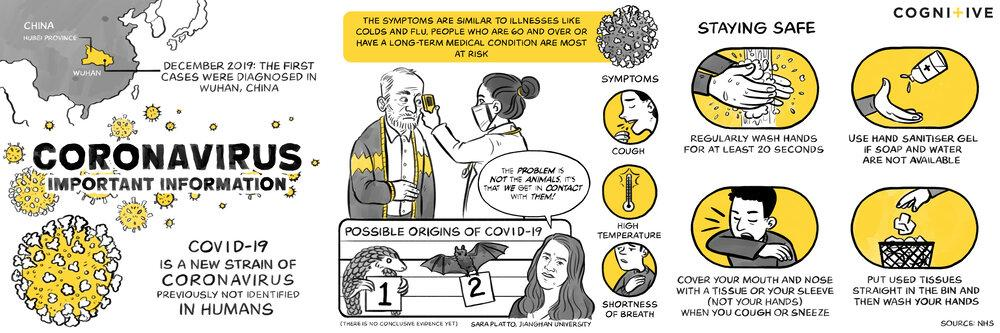Identify some key points in this picture. COUGH, HIGH TEMPERATURE, SHORTNESS OF BREATH are common symptoms of COVID-19. 